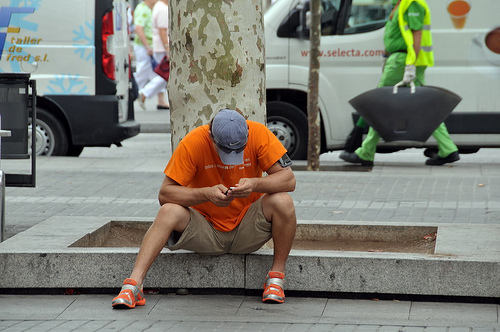Read all the text in this image. www.selecta.com taller da 